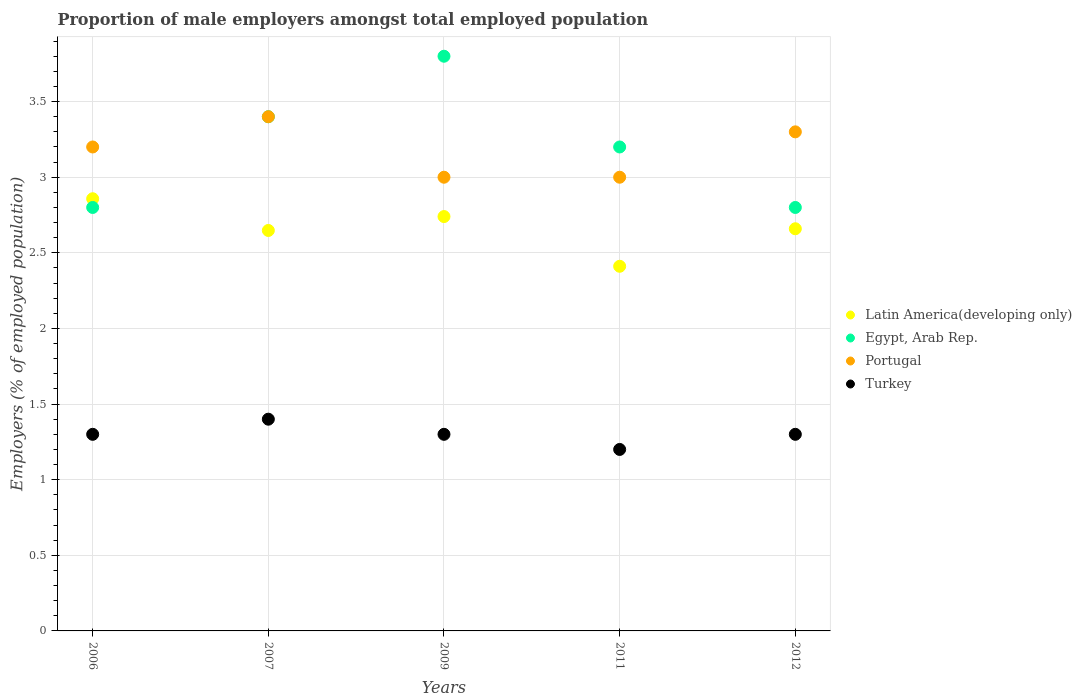What is the proportion of male employers in Latin America(developing only) in 2012?
Ensure brevity in your answer.  2.66. Across all years, what is the maximum proportion of male employers in Portugal?
Ensure brevity in your answer.  3.4. Across all years, what is the minimum proportion of male employers in Egypt, Arab Rep.?
Your answer should be very brief. 2.8. What is the total proportion of male employers in Portugal in the graph?
Provide a short and direct response. 15.9. What is the difference between the proportion of male employers in Egypt, Arab Rep. in 2007 and that in 2012?
Your answer should be very brief. 0.6. What is the difference between the proportion of male employers in Latin America(developing only) in 2011 and the proportion of male employers in Portugal in 2007?
Your response must be concise. -0.99. What is the average proportion of male employers in Egypt, Arab Rep. per year?
Keep it short and to the point. 3.2. In how many years, is the proportion of male employers in Latin America(developing only) greater than 3.2 %?
Offer a very short reply. 0. What is the ratio of the proportion of male employers in Portugal in 2009 to that in 2012?
Provide a succinct answer. 0.91. Is the difference between the proportion of male employers in Egypt, Arab Rep. in 2011 and 2012 greater than the difference between the proportion of male employers in Portugal in 2011 and 2012?
Give a very brief answer. Yes. What is the difference between the highest and the second highest proportion of male employers in Latin America(developing only)?
Make the answer very short. 0.12. What is the difference between the highest and the lowest proportion of male employers in Portugal?
Your answer should be very brief. 0.4. In how many years, is the proportion of male employers in Turkey greater than the average proportion of male employers in Turkey taken over all years?
Keep it short and to the point. 1. Is the sum of the proportion of male employers in Turkey in 2009 and 2012 greater than the maximum proportion of male employers in Portugal across all years?
Provide a succinct answer. No. Is it the case that in every year, the sum of the proportion of male employers in Latin America(developing only) and proportion of male employers in Egypt, Arab Rep.  is greater than the sum of proportion of male employers in Turkey and proportion of male employers in Portugal?
Keep it short and to the point. No. Is it the case that in every year, the sum of the proportion of male employers in Turkey and proportion of male employers in Latin America(developing only)  is greater than the proportion of male employers in Egypt, Arab Rep.?
Provide a succinct answer. Yes. Does the proportion of male employers in Latin America(developing only) monotonically increase over the years?
Ensure brevity in your answer.  No. Is the proportion of male employers in Portugal strictly greater than the proportion of male employers in Latin America(developing only) over the years?
Your answer should be very brief. Yes. Is the proportion of male employers in Latin America(developing only) strictly less than the proportion of male employers in Portugal over the years?
Your response must be concise. Yes. How many dotlines are there?
Your answer should be compact. 4. What is the difference between two consecutive major ticks on the Y-axis?
Offer a terse response. 0.5. How many legend labels are there?
Your answer should be compact. 4. What is the title of the graph?
Your answer should be compact. Proportion of male employers amongst total employed population. Does "Pacific island small states" appear as one of the legend labels in the graph?
Your response must be concise. No. What is the label or title of the Y-axis?
Your answer should be compact. Employers (% of employed population). What is the Employers (% of employed population) in Latin America(developing only) in 2006?
Keep it short and to the point. 2.86. What is the Employers (% of employed population) of Egypt, Arab Rep. in 2006?
Provide a succinct answer. 2.8. What is the Employers (% of employed population) of Portugal in 2006?
Your answer should be compact. 3.2. What is the Employers (% of employed population) of Turkey in 2006?
Your answer should be compact. 1.3. What is the Employers (% of employed population) in Latin America(developing only) in 2007?
Keep it short and to the point. 2.65. What is the Employers (% of employed population) of Egypt, Arab Rep. in 2007?
Keep it short and to the point. 3.4. What is the Employers (% of employed population) in Portugal in 2007?
Your answer should be compact. 3.4. What is the Employers (% of employed population) of Turkey in 2007?
Ensure brevity in your answer.  1.4. What is the Employers (% of employed population) of Latin America(developing only) in 2009?
Provide a short and direct response. 2.74. What is the Employers (% of employed population) of Egypt, Arab Rep. in 2009?
Provide a short and direct response. 3.8. What is the Employers (% of employed population) in Turkey in 2009?
Your response must be concise. 1.3. What is the Employers (% of employed population) of Latin America(developing only) in 2011?
Give a very brief answer. 2.41. What is the Employers (% of employed population) in Egypt, Arab Rep. in 2011?
Give a very brief answer. 3.2. What is the Employers (% of employed population) of Turkey in 2011?
Your answer should be very brief. 1.2. What is the Employers (% of employed population) in Latin America(developing only) in 2012?
Provide a short and direct response. 2.66. What is the Employers (% of employed population) in Egypt, Arab Rep. in 2012?
Your answer should be very brief. 2.8. What is the Employers (% of employed population) of Portugal in 2012?
Provide a succinct answer. 3.3. What is the Employers (% of employed population) in Turkey in 2012?
Ensure brevity in your answer.  1.3. Across all years, what is the maximum Employers (% of employed population) in Latin America(developing only)?
Ensure brevity in your answer.  2.86. Across all years, what is the maximum Employers (% of employed population) in Egypt, Arab Rep.?
Ensure brevity in your answer.  3.8. Across all years, what is the maximum Employers (% of employed population) in Portugal?
Offer a terse response. 3.4. Across all years, what is the maximum Employers (% of employed population) of Turkey?
Make the answer very short. 1.4. Across all years, what is the minimum Employers (% of employed population) of Latin America(developing only)?
Provide a succinct answer. 2.41. Across all years, what is the minimum Employers (% of employed population) in Egypt, Arab Rep.?
Your response must be concise. 2.8. Across all years, what is the minimum Employers (% of employed population) in Turkey?
Your response must be concise. 1.2. What is the total Employers (% of employed population) of Latin America(developing only) in the graph?
Your answer should be very brief. 13.32. What is the total Employers (% of employed population) in Portugal in the graph?
Keep it short and to the point. 15.9. What is the difference between the Employers (% of employed population) of Latin America(developing only) in 2006 and that in 2007?
Your answer should be very brief. 0.21. What is the difference between the Employers (% of employed population) in Portugal in 2006 and that in 2007?
Your answer should be very brief. -0.2. What is the difference between the Employers (% of employed population) in Turkey in 2006 and that in 2007?
Your answer should be very brief. -0.1. What is the difference between the Employers (% of employed population) in Latin America(developing only) in 2006 and that in 2009?
Your answer should be very brief. 0.12. What is the difference between the Employers (% of employed population) of Egypt, Arab Rep. in 2006 and that in 2009?
Provide a succinct answer. -1. What is the difference between the Employers (% of employed population) of Portugal in 2006 and that in 2009?
Provide a succinct answer. 0.2. What is the difference between the Employers (% of employed population) in Turkey in 2006 and that in 2009?
Ensure brevity in your answer.  0. What is the difference between the Employers (% of employed population) in Latin America(developing only) in 2006 and that in 2011?
Keep it short and to the point. 0.45. What is the difference between the Employers (% of employed population) of Latin America(developing only) in 2006 and that in 2012?
Provide a short and direct response. 0.2. What is the difference between the Employers (% of employed population) in Egypt, Arab Rep. in 2006 and that in 2012?
Offer a very short reply. 0. What is the difference between the Employers (% of employed population) in Turkey in 2006 and that in 2012?
Provide a short and direct response. 0. What is the difference between the Employers (% of employed population) of Latin America(developing only) in 2007 and that in 2009?
Ensure brevity in your answer.  -0.09. What is the difference between the Employers (% of employed population) in Turkey in 2007 and that in 2009?
Offer a very short reply. 0.1. What is the difference between the Employers (% of employed population) in Latin America(developing only) in 2007 and that in 2011?
Provide a short and direct response. 0.24. What is the difference between the Employers (% of employed population) in Egypt, Arab Rep. in 2007 and that in 2011?
Offer a terse response. 0.2. What is the difference between the Employers (% of employed population) of Portugal in 2007 and that in 2011?
Your answer should be very brief. 0.4. What is the difference between the Employers (% of employed population) of Turkey in 2007 and that in 2011?
Your response must be concise. 0.2. What is the difference between the Employers (% of employed population) of Latin America(developing only) in 2007 and that in 2012?
Your response must be concise. -0.01. What is the difference between the Employers (% of employed population) in Egypt, Arab Rep. in 2007 and that in 2012?
Your answer should be compact. 0.6. What is the difference between the Employers (% of employed population) of Latin America(developing only) in 2009 and that in 2011?
Your answer should be compact. 0.33. What is the difference between the Employers (% of employed population) of Egypt, Arab Rep. in 2009 and that in 2011?
Provide a short and direct response. 0.6. What is the difference between the Employers (% of employed population) of Portugal in 2009 and that in 2011?
Keep it short and to the point. 0. What is the difference between the Employers (% of employed population) in Turkey in 2009 and that in 2011?
Your answer should be compact. 0.1. What is the difference between the Employers (% of employed population) of Latin America(developing only) in 2009 and that in 2012?
Offer a very short reply. 0.08. What is the difference between the Employers (% of employed population) in Latin America(developing only) in 2011 and that in 2012?
Your answer should be compact. -0.25. What is the difference between the Employers (% of employed population) of Egypt, Arab Rep. in 2011 and that in 2012?
Provide a succinct answer. 0.4. What is the difference between the Employers (% of employed population) in Turkey in 2011 and that in 2012?
Your response must be concise. -0.1. What is the difference between the Employers (% of employed population) of Latin America(developing only) in 2006 and the Employers (% of employed population) of Egypt, Arab Rep. in 2007?
Your answer should be very brief. -0.54. What is the difference between the Employers (% of employed population) of Latin America(developing only) in 2006 and the Employers (% of employed population) of Portugal in 2007?
Offer a terse response. -0.54. What is the difference between the Employers (% of employed population) of Latin America(developing only) in 2006 and the Employers (% of employed population) of Turkey in 2007?
Offer a terse response. 1.46. What is the difference between the Employers (% of employed population) in Egypt, Arab Rep. in 2006 and the Employers (% of employed population) in Portugal in 2007?
Offer a very short reply. -0.6. What is the difference between the Employers (% of employed population) of Egypt, Arab Rep. in 2006 and the Employers (% of employed population) of Turkey in 2007?
Your answer should be very brief. 1.4. What is the difference between the Employers (% of employed population) in Portugal in 2006 and the Employers (% of employed population) in Turkey in 2007?
Your response must be concise. 1.8. What is the difference between the Employers (% of employed population) in Latin America(developing only) in 2006 and the Employers (% of employed population) in Egypt, Arab Rep. in 2009?
Your answer should be compact. -0.94. What is the difference between the Employers (% of employed population) in Latin America(developing only) in 2006 and the Employers (% of employed population) in Portugal in 2009?
Offer a very short reply. -0.14. What is the difference between the Employers (% of employed population) of Latin America(developing only) in 2006 and the Employers (% of employed population) of Turkey in 2009?
Your answer should be very brief. 1.56. What is the difference between the Employers (% of employed population) of Egypt, Arab Rep. in 2006 and the Employers (% of employed population) of Portugal in 2009?
Ensure brevity in your answer.  -0.2. What is the difference between the Employers (% of employed population) in Egypt, Arab Rep. in 2006 and the Employers (% of employed population) in Turkey in 2009?
Your answer should be very brief. 1.5. What is the difference between the Employers (% of employed population) in Portugal in 2006 and the Employers (% of employed population) in Turkey in 2009?
Your answer should be very brief. 1.9. What is the difference between the Employers (% of employed population) in Latin America(developing only) in 2006 and the Employers (% of employed population) in Egypt, Arab Rep. in 2011?
Offer a terse response. -0.34. What is the difference between the Employers (% of employed population) in Latin America(developing only) in 2006 and the Employers (% of employed population) in Portugal in 2011?
Keep it short and to the point. -0.14. What is the difference between the Employers (% of employed population) of Latin America(developing only) in 2006 and the Employers (% of employed population) of Turkey in 2011?
Ensure brevity in your answer.  1.66. What is the difference between the Employers (% of employed population) in Egypt, Arab Rep. in 2006 and the Employers (% of employed population) in Portugal in 2011?
Your answer should be compact. -0.2. What is the difference between the Employers (% of employed population) in Egypt, Arab Rep. in 2006 and the Employers (% of employed population) in Turkey in 2011?
Keep it short and to the point. 1.6. What is the difference between the Employers (% of employed population) of Portugal in 2006 and the Employers (% of employed population) of Turkey in 2011?
Provide a short and direct response. 2. What is the difference between the Employers (% of employed population) of Latin America(developing only) in 2006 and the Employers (% of employed population) of Egypt, Arab Rep. in 2012?
Ensure brevity in your answer.  0.06. What is the difference between the Employers (% of employed population) of Latin America(developing only) in 2006 and the Employers (% of employed population) of Portugal in 2012?
Your answer should be very brief. -0.44. What is the difference between the Employers (% of employed population) in Latin America(developing only) in 2006 and the Employers (% of employed population) in Turkey in 2012?
Give a very brief answer. 1.56. What is the difference between the Employers (% of employed population) in Egypt, Arab Rep. in 2006 and the Employers (% of employed population) in Portugal in 2012?
Offer a terse response. -0.5. What is the difference between the Employers (% of employed population) in Egypt, Arab Rep. in 2006 and the Employers (% of employed population) in Turkey in 2012?
Offer a terse response. 1.5. What is the difference between the Employers (% of employed population) in Portugal in 2006 and the Employers (% of employed population) in Turkey in 2012?
Give a very brief answer. 1.9. What is the difference between the Employers (% of employed population) of Latin America(developing only) in 2007 and the Employers (% of employed population) of Egypt, Arab Rep. in 2009?
Offer a very short reply. -1.15. What is the difference between the Employers (% of employed population) in Latin America(developing only) in 2007 and the Employers (% of employed population) in Portugal in 2009?
Provide a short and direct response. -0.35. What is the difference between the Employers (% of employed population) of Latin America(developing only) in 2007 and the Employers (% of employed population) of Turkey in 2009?
Your answer should be very brief. 1.35. What is the difference between the Employers (% of employed population) in Portugal in 2007 and the Employers (% of employed population) in Turkey in 2009?
Offer a terse response. 2.1. What is the difference between the Employers (% of employed population) in Latin America(developing only) in 2007 and the Employers (% of employed population) in Egypt, Arab Rep. in 2011?
Provide a short and direct response. -0.55. What is the difference between the Employers (% of employed population) of Latin America(developing only) in 2007 and the Employers (% of employed population) of Portugal in 2011?
Offer a very short reply. -0.35. What is the difference between the Employers (% of employed population) of Latin America(developing only) in 2007 and the Employers (% of employed population) of Turkey in 2011?
Your answer should be very brief. 1.45. What is the difference between the Employers (% of employed population) in Portugal in 2007 and the Employers (% of employed population) in Turkey in 2011?
Your response must be concise. 2.2. What is the difference between the Employers (% of employed population) in Latin America(developing only) in 2007 and the Employers (% of employed population) in Egypt, Arab Rep. in 2012?
Offer a terse response. -0.15. What is the difference between the Employers (% of employed population) of Latin America(developing only) in 2007 and the Employers (% of employed population) of Portugal in 2012?
Your response must be concise. -0.65. What is the difference between the Employers (% of employed population) in Latin America(developing only) in 2007 and the Employers (% of employed population) in Turkey in 2012?
Your answer should be compact. 1.35. What is the difference between the Employers (% of employed population) of Portugal in 2007 and the Employers (% of employed population) of Turkey in 2012?
Ensure brevity in your answer.  2.1. What is the difference between the Employers (% of employed population) of Latin America(developing only) in 2009 and the Employers (% of employed population) of Egypt, Arab Rep. in 2011?
Your answer should be very brief. -0.46. What is the difference between the Employers (% of employed population) in Latin America(developing only) in 2009 and the Employers (% of employed population) in Portugal in 2011?
Ensure brevity in your answer.  -0.26. What is the difference between the Employers (% of employed population) of Latin America(developing only) in 2009 and the Employers (% of employed population) of Turkey in 2011?
Provide a succinct answer. 1.54. What is the difference between the Employers (% of employed population) in Egypt, Arab Rep. in 2009 and the Employers (% of employed population) in Turkey in 2011?
Offer a terse response. 2.6. What is the difference between the Employers (% of employed population) of Portugal in 2009 and the Employers (% of employed population) of Turkey in 2011?
Provide a succinct answer. 1.8. What is the difference between the Employers (% of employed population) in Latin America(developing only) in 2009 and the Employers (% of employed population) in Egypt, Arab Rep. in 2012?
Your answer should be compact. -0.06. What is the difference between the Employers (% of employed population) in Latin America(developing only) in 2009 and the Employers (% of employed population) in Portugal in 2012?
Keep it short and to the point. -0.56. What is the difference between the Employers (% of employed population) in Latin America(developing only) in 2009 and the Employers (% of employed population) in Turkey in 2012?
Offer a terse response. 1.44. What is the difference between the Employers (% of employed population) in Egypt, Arab Rep. in 2009 and the Employers (% of employed population) in Turkey in 2012?
Offer a terse response. 2.5. What is the difference between the Employers (% of employed population) of Portugal in 2009 and the Employers (% of employed population) of Turkey in 2012?
Give a very brief answer. 1.7. What is the difference between the Employers (% of employed population) of Latin America(developing only) in 2011 and the Employers (% of employed population) of Egypt, Arab Rep. in 2012?
Ensure brevity in your answer.  -0.39. What is the difference between the Employers (% of employed population) of Latin America(developing only) in 2011 and the Employers (% of employed population) of Portugal in 2012?
Ensure brevity in your answer.  -0.89. What is the difference between the Employers (% of employed population) in Latin America(developing only) in 2011 and the Employers (% of employed population) in Turkey in 2012?
Keep it short and to the point. 1.11. What is the difference between the Employers (% of employed population) in Egypt, Arab Rep. in 2011 and the Employers (% of employed population) in Portugal in 2012?
Your answer should be very brief. -0.1. What is the difference between the Employers (% of employed population) of Portugal in 2011 and the Employers (% of employed population) of Turkey in 2012?
Your response must be concise. 1.7. What is the average Employers (% of employed population) of Latin America(developing only) per year?
Provide a short and direct response. 2.66. What is the average Employers (% of employed population) in Portugal per year?
Offer a terse response. 3.18. In the year 2006, what is the difference between the Employers (% of employed population) in Latin America(developing only) and Employers (% of employed population) in Egypt, Arab Rep.?
Provide a short and direct response. 0.06. In the year 2006, what is the difference between the Employers (% of employed population) of Latin America(developing only) and Employers (% of employed population) of Portugal?
Your answer should be very brief. -0.34. In the year 2006, what is the difference between the Employers (% of employed population) in Latin America(developing only) and Employers (% of employed population) in Turkey?
Provide a short and direct response. 1.56. In the year 2006, what is the difference between the Employers (% of employed population) in Egypt, Arab Rep. and Employers (% of employed population) in Portugal?
Offer a very short reply. -0.4. In the year 2006, what is the difference between the Employers (% of employed population) in Egypt, Arab Rep. and Employers (% of employed population) in Turkey?
Make the answer very short. 1.5. In the year 2006, what is the difference between the Employers (% of employed population) of Portugal and Employers (% of employed population) of Turkey?
Make the answer very short. 1.9. In the year 2007, what is the difference between the Employers (% of employed population) in Latin America(developing only) and Employers (% of employed population) in Egypt, Arab Rep.?
Ensure brevity in your answer.  -0.75. In the year 2007, what is the difference between the Employers (% of employed population) in Latin America(developing only) and Employers (% of employed population) in Portugal?
Offer a terse response. -0.75. In the year 2007, what is the difference between the Employers (% of employed population) of Latin America(developing only) and Employers (% of employed population) of Turkey?
Your response must be concise. 1.25. In the year 2007, what is the difference between the Employers (% of employed population) of Egypt, Arab Rep. and Employers (% of employed population) of Portugal?
Provide a succinct answer. 0. In the year 2007, what is the difference between the Employers (% of employed population) of Portugal and Employers (% of employed population) of Turkey?
Offer a very short reply. 2. In the year 2009, what is the difference between the Employers (% of employed population) in Latin America(developing only) and Employers (% of employed population) in Egypt, Arab Rep.?
Give a very brief answer. -1.06. In the year 2009, what is the difference between the Employers (% of employed population) in Latin America(developing only) and Employers (% of employed population) in Portugal?
Provide a succinct answer. -0.26. In the year 2009, what is the difference between the Employers (% of employed population) in Latin America(developing only) and Employers (% of employed population) in Turkey?
Your answer should be compact. 1.44. In the year 2011, what is the difference between the Employers (% of employed population) in Latin America(developing only) and Employers (% of employed population) in Egypt, Arab Rep.?
Give a very brief answer. -0.79. In the year 2011, what is the difference between the Employers (% of employed population) in Latin America(developing only) and Employers (% of employed population) in Portugal?
Offer a terse response. -0.59. In the year 2011, what is the difference between the Employers (% of employed population) in Latin America(developing only) and Employers (% of employed population) in Turkey?
Keep it short and to the point. 1.21. In the year 2011, what is the difference between the Employers (% of employed population) of Egypt, Arab Rep. and Employers (% of employed population) of Portugal?
Offer a terse response. 0.2. In the year 2012, what is the difference between the Employers (% of employed population) in Latin America(developing only) and Employers (% of employed population) in Egypt, Arab Rep.?
Offer a very short reply. -0.14. In the year 2012, what is the difference between the Employers (% of employed population) of Latin America(developing only) and Employers (% of employed population) of Portugal?
Ensure brevity in your answer.  -0.64. In the year 2012, what is the difference between the Employers (% of employed population) of Latin America(developing only) and Employers (% of employed population) of Turkey?
Provide a succinct answer. 1.36. In the year 2012, what is the difference between the Employers (% of employed population) of Egypt, Arab Rep. and Employers (% of employed population) of Portugal?
Your response must be concise. -0.5. In the year 2012, what is the difference between the Employers (% of employed population) in Egypt, Arab Rep. and Employers (% of employed population) in Turkey?
Your answer should be compact. 1.5. What is the ratio of the Employers (% of employed population) in Latin America(developing only) in 2006 to that in 2007?
Provide a short and direct response. 1.08. What is the ratio of the Employers (% of employed population) in Egypt, Arab Rep. in 2006 to that in 2007?
Offer a terse response. 0.82. What is the ratio of the Employers (% of employed population) of Turkey in 2006 to that in 2007?
Offer a terse response. 0.93. What is the ratio of the Employers (% of employed population) in Latin America(developing only) in 2006 to that in 2009?
Offer a very short reply. 1.04. What is the ratio of the Employers (% of employed population) of Egypt, Arab Rep. in 2006 to that in 2009?
Your answer should be compact. 0.74. What is the ratio of the Employers (% of employed population) of Portugal in 2006 to that in 2009?
Your answer should be very brief. 1.07. What is the ratio of the Employers (% of employed population) in Turkey in 2006 to that in 2009?
Ensure brevity in your answer.  1. What is the ratio of the Employers (% of employed population) in Latin America(developing only) in 2006 to that in 2011?
Make the answer very short. 1.19. What is the ratio of the Employers (% of employed population) of Egypt, Arab Rep. in 2006 to that in 2011?
Offer a very short reply. 0.88. What is the ratio of the Employers (% of employed population) in Portugal in 2006 to that in 2011?
Offer a terse response. 1.07. What is the ratio of the Employers (% of employed population) of Latin America(developing only) in 2006 to that in 2012?
Keep it short and to the point. 1.07. What is the ratio of the Employers (% of employed population) in Egypt, Arab Rep. in 2006 to that in 2012?
Your answer should be compact. 1. What is the ratio of the Employers (% of employed population) of Portugal in 2006 to that in 2012?
Keep it short and to the point. 0.97. What is the ratio of the Employers (% of employed population) in Turkey in 2006 to that in 2012?
Your response must be concise. 1. What is the ratio of the Employers (% of employed population) in Latin America(developing only) in 2007 to that in 2009?
Offer a terse response. 0.97. What is the ratio of the Employers (% of employed population) of Egypt, Arab Rep. in 2007 to that in 2009?
Keep it short and to the point. 0.89. What is the ratio of the Employers (% of employed population) in Portugal in 2007 to that in 2009?
Provide a short and direct response. 1.13. What is the ratio of the Employers (% of employed population) in Turkey in 2007 to that in 2009?
Provide a short and direct response. 1.08. What is the ratio of the Employers (% of employed population) in Latin America(developing only) in 2007 to that in 2011?
Your answer should be very brief. 1.1. What is the ratio of the Employers (% of employed population) of Portugal in 2007 to that in 2011?
Provide a succinct answer. 1.13. What is the ratio of the Employers (% of employed population) of Turkey in 2007 to that in 2011?
Offer a terse response. 1.17. What is the ratio of the Employers (% of employed population) of Latin America(developing only) in 2007 to that in 2012?
Provide a short and direct response. 1. What is the ratio of the Employers (% of employed population) of Egypt, Arab Rep. in 2007 to that in 2012?
Your answer should be very brief. 1.21. What is the ratio of the Employers (% of employed population) in Portugal in 2007 to that in 2012?
Provide a short and direct response. 1.03. What is the ratio of the Employers (% of employed population) of Turkey in 2007 to that in 2012?
Offer a very short reply. 1.08. What is the ratio of the Employers (% of employed population) in Latin America(developing only) in 2009 to that in 2011?
Make the answer very short. 1.14. What is the ratio of the Employers (% of employed population) of Egypt, Arab Rep. in 2009 to that in 2011?
Provide a succinct answer. 1.19. What is the ratio of the Employers (% of employed population) in Portugal in 2009 to that in 2011?
Your response must be concise. 1. What is the ratio of the Employers (% of employed population) of Latin America(developing only) in 2009 to that in 2012?
Keep it short and to the point. 1.03. What is the ratio of the Employers (% of employed population) in Egypt, Arab Rep. in 2009 to that in 2012?
Your response must be concise. 1.36. What is the ratio of the Employers (% of employed population) in Turkey in 2009 to that in 2012?
Your answer should be very brief. 1. What is the ratio of the Employers (% of employed population) of Latin America(developing only) in 2011 to that in 2012?
Your response must be concise. 0.91. What is the ratio of the Employers (% of employed population) of Egypt, Arab Rep. in 2011 to that in 2012?
Offer a terse response. 1.14. What is the difference between the highest and the second highest Employers (% of employed population) in Latin America(developing only)?
Your response must be concise. 0.12. What is the difference between the highest and the lowest Employers (% of employed population) of Latin America(developing only)?
Offer a very short reply. 0.45. What is the difference between the highest and the lowest Employers (% of employed population) in Egypt, Arab Rep.?
Ensure brevity in your answer.  1. 